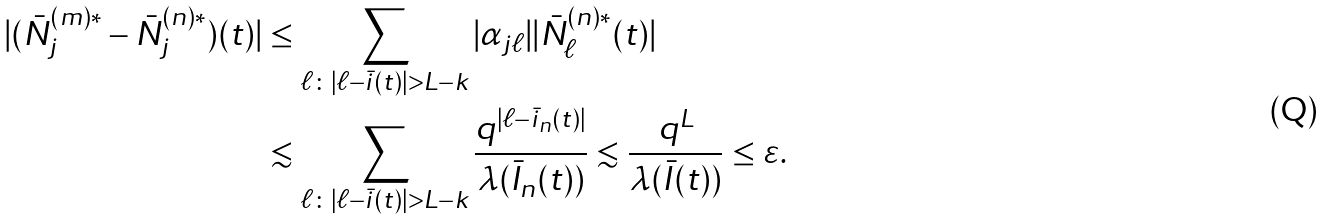<formula> <loc_0><loc_0><loc_500><loc_500>| ( \bar { N } _ { j } ^ { ( m ) * } - \bar { N } _ { j } ^ { ( n ) * } ) ( t ) | & \leq \sum _ { \ell \colon | \ell - \bar { i } ( t ) | > L - k } | \alpha _ { j \ell } | | \bar { N } _ { \ell } ^ { ( n ) * } ( t ) | \\ & \lesssim \sum _ { \ell \colon | \ell - \bar { i } ( t ) | > L - k } \frac { q ^ { | \ell - \bar { i } _ { n } ( t ) | } } { \lambda ( \bar { I } _ { n } ( t ) ) } \lesssim \frac { q ^ { L } } { \lambda ( \bar { I } ( t ) ) } \leq \varepsilon .</formula> 